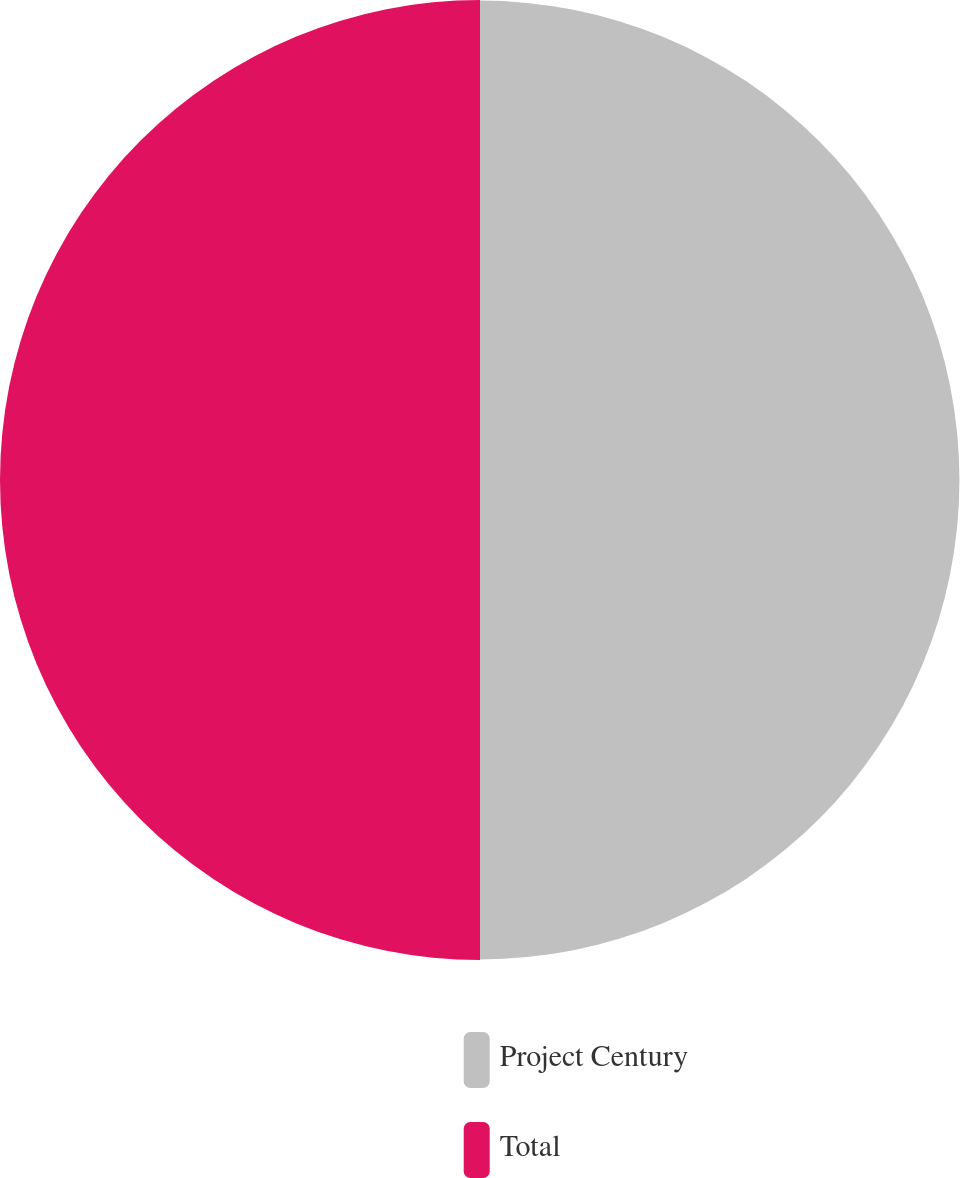Convert chart to OTSL. <chart><loc_0><loc_0><loc_500><loc_500><pie_chart><fcel>Project Century<fcel>Total<nl><fcel>49.97%<fcel>50.03%<nl></chart> 